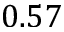<formula> <loc_0><loc_0><loc_500><loc_500>0 . 5 7</formula> 